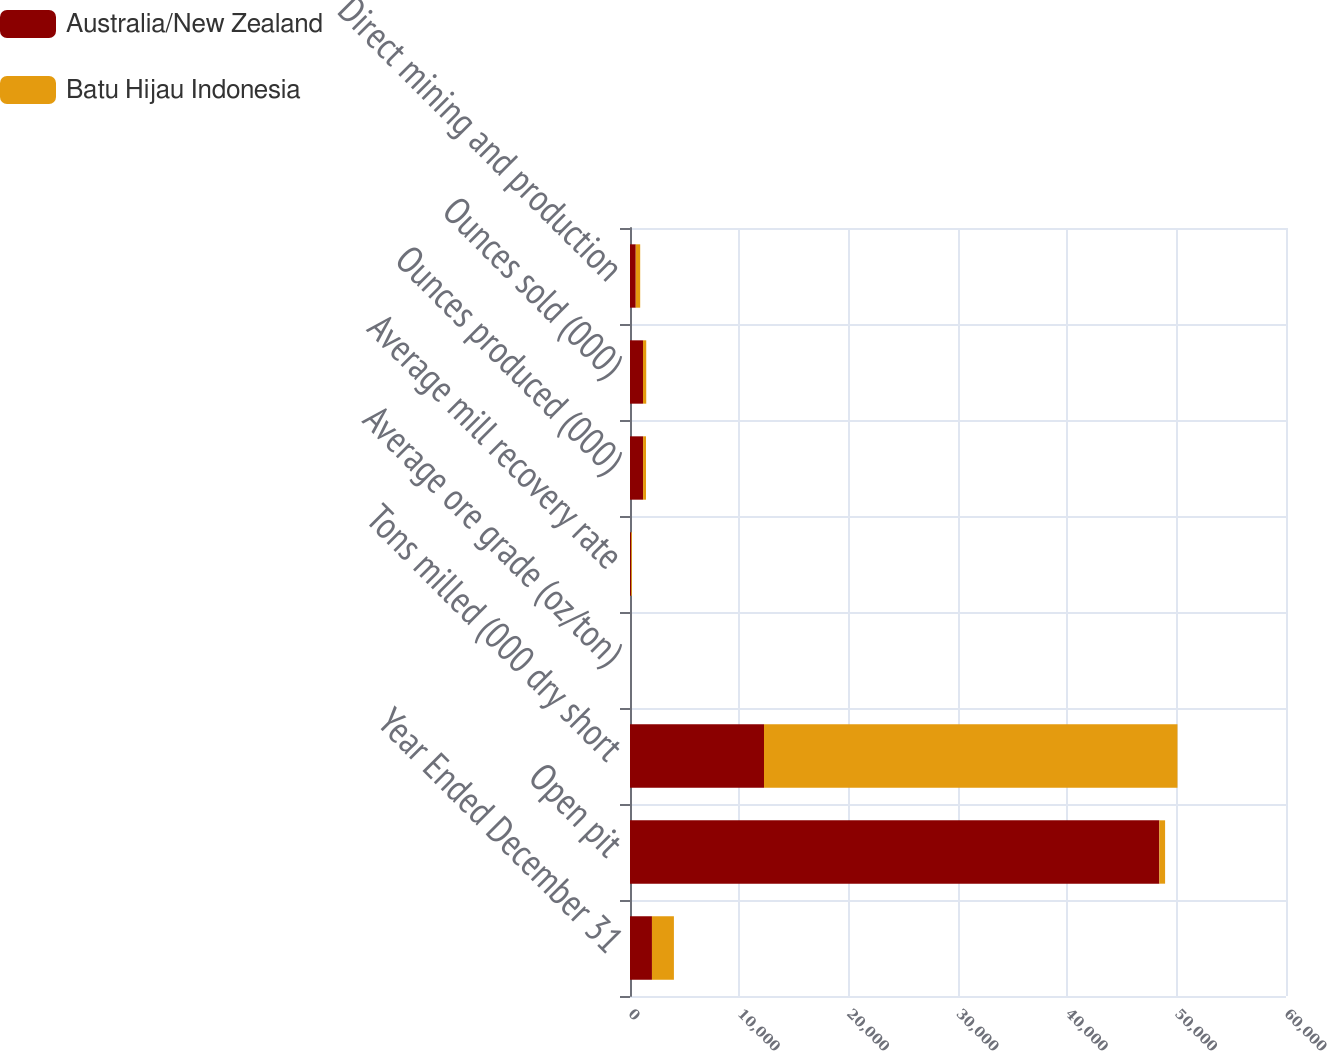Convert chart. <chart><loc_0><loc_0><loc_500><loc_500><stacked_bar_chart><ecel><fcel>Year Ended December 31<fcel>Open pit<fcel>Tons milled (000 dry short<fcel>Average ore grade (oz/ton)<fcel>Average mill recovery rate<fcel>Ounces produced (000)<fcel>Ounces sold (000)<fcel>Direct mining and production<nl><fcel>Australia/New Zealand<fcel>2008<fcel>48416<fcel>12256<fcel>0.11<fcel>91.5<fcel>1195<fcel>1187<fcel>526<nl><fcel>Batu Hijau Indonesia<fcel>2008<fcel>526<fcel>37818<fcel>0.01<fcel>75.2<fcel>269<fcel>299<fcel>406<nl></chart> 